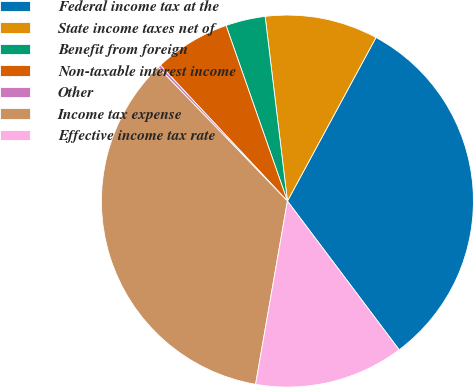Convert chart to OTSL. <chart><loc_0><loc_0><loc_500><loc_500><pie_chart><fcel>Federal income tax at the<fcel>State income taxes net of<fcel>Benefit from foreign<fcel>Non-taxable interest income<fcel>Other<fcel>Income tax expense<fcel>Effective income tax rate<nl><fcel>31.85%<fcel>9.81%<fcel>3.44%<fcel>6.62%<fcel>0.25%<fcel>35.04%<fcel>12.99%<nl></chart> 